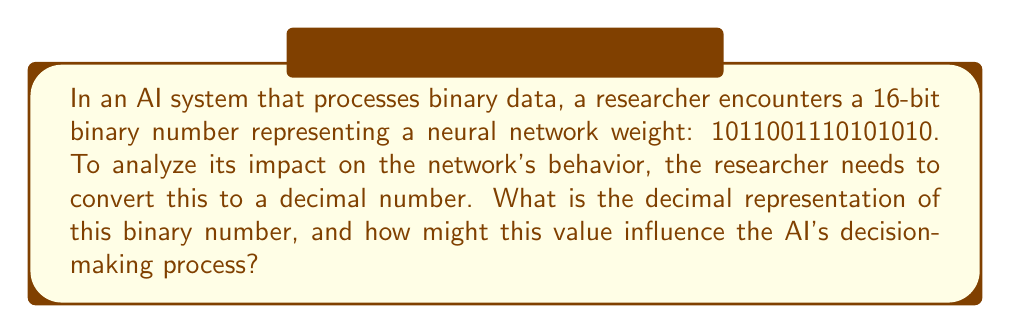Give your solution to this math problem. To convert a binary number to decimal, we multiply each bit by its corresponding power of 2 and sum the results. The rightmost bit represents $2^0$, the next bit $2^1$, and so on.

Let's break down the conversion process:

1) First, we'll number each bit from right to left, starting with 0:

   $1011001110101010$
   $15......................0$

2) Now, we'll multiply each '1' bit by its corresponding power of 2:

   $1 \cdot 2^{15} = 32768$
   $0 \cdot 2^{14} = 0$
   $1 \cdot 2^{13} = 8192$
   $1 \cdot 2^{12} = 4096$
   $0 \cdot 2^{11} = 0$
   $0 \cdot 2^{10} = 0$
   $1 \cdot 2^9 = 512$
   $1 \cdot 2^8 = 256$
   $1 \cdot 2^7 = 128$
   $0 \cdot 2^6 = 0$
   $1 \cdot 2^5 = 32$
   $0 \cdot 2^4 = 0$
   $1 \cdot 2^3 = 8$
   $0 \cdot 2^2 = 0$
   $1 \cdot 2^1 = 2$
   $0 \cdot 2^0 = 0$

3) Sum all these values:

   $32768 + 8192 + 4096 + 512 + 256 + 128 + 32 + 8 + 2 = 45994$

Regarding the influence on the AI's decision-making process:

The value 45994 represents a weight in the neural network. In most neural network architectures, weights are typically normalized to be between -1 and 1 or 0 and 1. Therefore, this large integer value would likely be scaled down.

For instance, if we assume a 16-bit fixed-point representation with 8 bits for the integer part and 8 bits for the fractional part, the actual weight value would be:

$45994 / 2^8 = 179.6640625$

This scaled value suggests a strong positive weight, which could significantly amplify the input it's associated with, potentially leading to a more decisive output in that direction. However, the exact impact would depend on the specific architecture and activation functions used in the AI system.
Answer: The decimal representation of the binary number 1011001110101010 is 45994. 